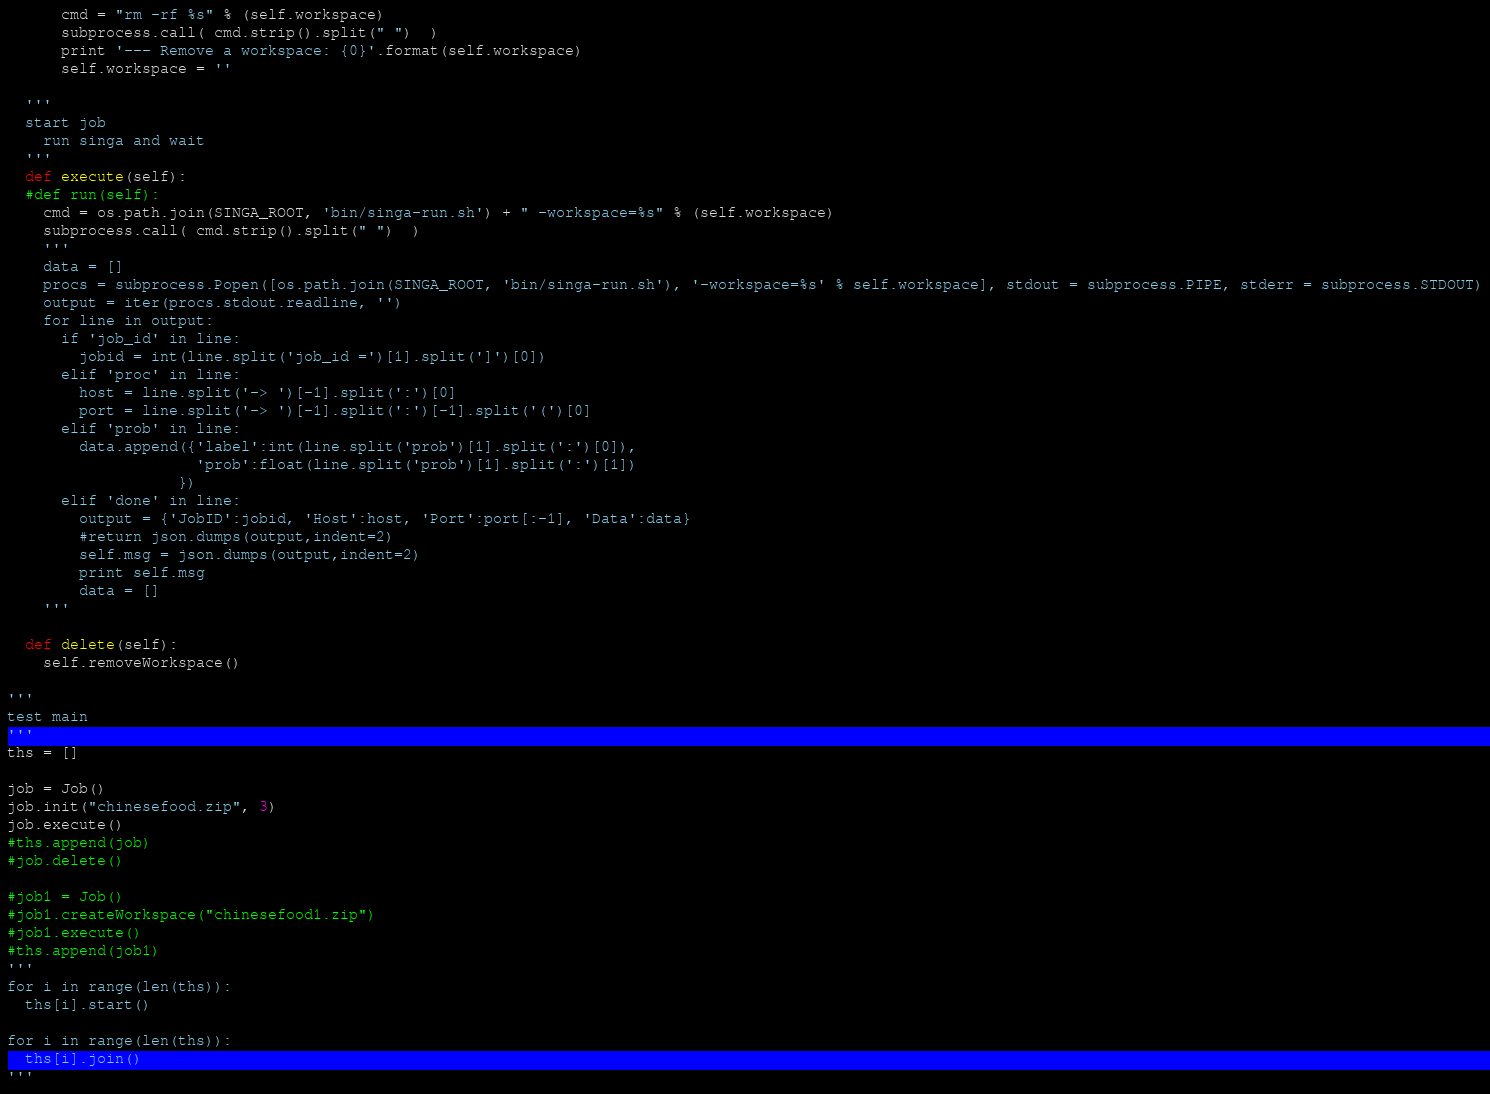<code> <loc_0><loc_0><loc_500><loc_500><_Python_>      cmd = "rm -rf %s" % (self.workspace)
      subprocess.call( cmd.strip().split(" ")  ) 
      print '--- Remove a workspace: {0}'.format(self.workspace)
      self.workspace = ''

  '''
  start job
    run singa and wait
  '''
  def execute(self):
  #def run(self):
    cmd = os.path.join(SINGA_ROOT, 'bin/singa-run.sh') + " -workspace=%s" % (self.workspace)
    subprocess.call( cmd.strip().split(" ")  ) 
    '''
    data = []
    procs = subprocess.Popen([os.path.join(SINGA_ROOT, 'bin/singa-run.sh'), '-workspace=%s' % self.workspace], stdout = subprocess.PIPE, stderr = subprocess.STDOUT)
    output = iter(procs.stdout.readline, '')
    for line in output:
      if 'job_id' in line:
        jobid = int(line.split('job_id =')[1].split(']')[0])
      elif 'proc' in line:
        host = line.split('-> ')[-1].split(':')[0]
        port = line.split('-> ')[-1].split(':')[-1].split('(')[0]
      elif 'prob' in line:
        data.append({'label':int(line.split('prob')[1].split(':')[0]),
                     'prob':float(line.split('prob')[1].split(':')[1])
                   })
      elif 'done' in line:
        output = {'JobID':jobid, 'Host':host, 'Port':port[:-1], 'Data':data}
        #return json.dumps(output,indent=2)
        self.msg = json.dumps(output,indent=2)
        print self.msg
        data = []
    '''

  def delete(self):
    self.removeWorkspace() 

'''
test main
'''
ths = []

job = Job()
job.init("chinesefood.zip", 3)
job.execute()
#ths.append(job)
#job.delete()

#job1 = Job()
#job1.createWorkspace("chinesefood1.zip")
#job1.execute()
#ths.append(job1)
'''
for i in range(len(ths)):
  ths[i].start()

for i in range(len(ths)):
  ths[i].join()
'''
</code> 